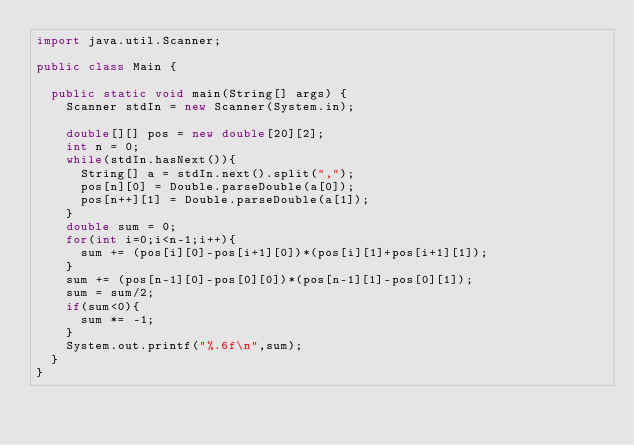<code> <loc_0><loc_0><loc_500><loc_500><_Java_>import java.util.Scanner;

public class Main {

	public static void main(String[] args) {
		Scanner stdIn = new Scanner(System.in);
		
		double[][] pos = new double[20][2];
		int n = 0;
		while(stdIn.hasNext()){
			String[] a = stdIn.next().split(",");
			pos[n][0] = Double.parseDouble(a[0]);
			pos[n++][1] = Double.parseDouble(a[1]);
		}
		double sum = 0;
		for(int i=0;i<n-1;i++){
			sum += (pos[i][0]-pos[i+1][0])*(pos[i][1]+pos[i+1][1]);
		}
		sum += (pos[n-1][0]-pos[0][0])*(pos[n-1][1]-pos[0][1]);
		sum = sum/2;
		if(sum<0){
			sum *= -1;
		}
		System.out.printf("%.6f\n",sum);
	}
}</code> 